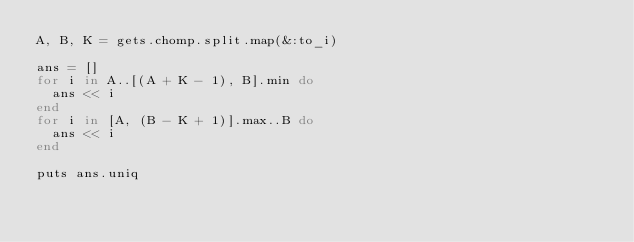Convert code to text. <code><loc_0><loc_0><loc_500><loc_500><_Ruby_>A, B, K = gets.chomp.split.map(&:to_i)

ans = []
for i in A..[(A + K - 1), B].min do
  ans << i
end
for i in [A, (B - K + 1)].max..B do
  ans << i
end

puts ans.uniq</code> 